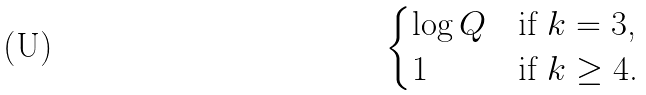<formula> <loc_0><loc_0><loc_500><loc_500>\begin{cases} \log Q & \text {if $k = 3$,} \\ 1 & \text {if $k \geq 4$.} \end{cases}</formula> 